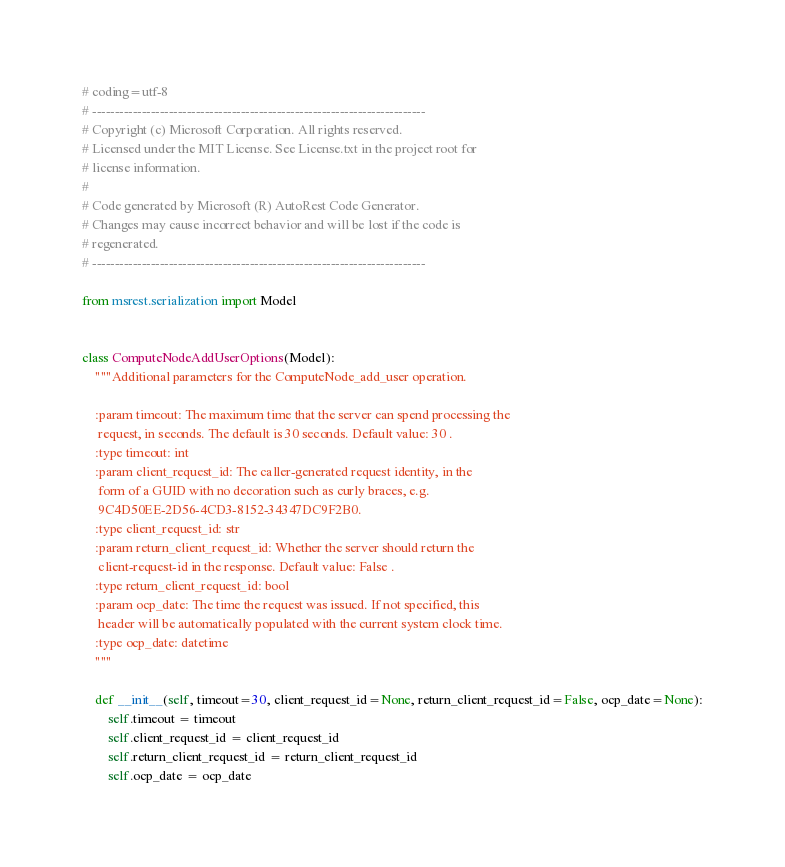<code> <loc_0><loc_0><loc_500><loc_500><_Python_># coding=utf-8
# --------------------------------------------------------------------------
# Copyright (c) Microsoft Corporation. All rights reserved.
# Licensed under the MIT License. See License.txt in the project root for
# license information.
#
# Code generated by Microsoft (R) AutoRest Code Generator.
# Changes may cause incorrect behavior and will be lost if the code is
# regenerated.
# --------------------------------------------------------------------------

from msrest.serialization import Model


class ComputeNodeAddUserOptions(Model):
    """Additional parameters for the ComputeNode_add_user operation.

    :param timeout: The maximum time that the server can spend processing the
     request, in seconds. The default is 30 seconds. Default value: 30 .
    :type timeout: int
    :param client_request_id: The caller-generated request identity, in the
     form of a GUID with no decoration such as curly braces, e.g.
     9C4D50EE-2D56-4CD3-8152-34347DC9F2B0.
    :type client_request_id: str
    :param return_client_request_id: Whether the server should return the
     client-request-id in the response. Default value: False .
    :type return_client_request_id: bool
    :param ocp_date: The time the request was issued. If not specified, this
     header will be automatically populated with the current system clock time.
    :type ocp_date: datetime
    """ 

    def __init__(self, timeout=30, client_request_id=None, return_client_request_id=False, ocp_date=None):
        self.timeout = timeout
        self.client_request_id = client_request_id
        self.return_client_request_id = return_client_request_id
        self.ocp_date = ocp_date
</code> 